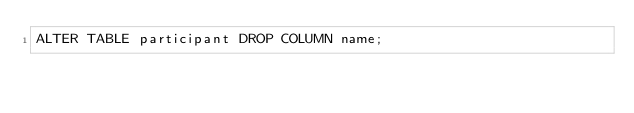Convert code to text. <code><loc_0><loc_0><loc_500><loc_500><_SQL_>ALTER TABLE participant DROP COLUMN name;</code> 